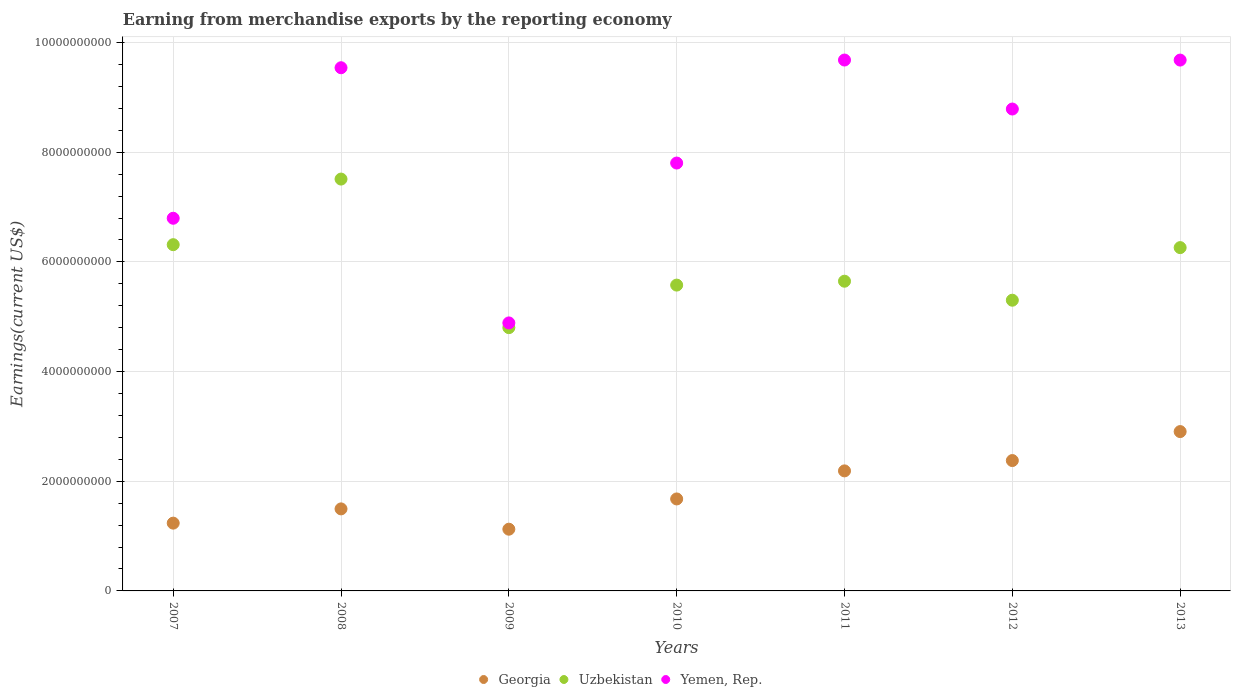How many different coloured dotlines are there?
Your answer should be very brief. 3. What is the amount earned from merchandise exports in Uzbekistan in 2009?
Ensure brevity in your answer.  4.80e+09. Across all years, what is the maximum amount earned from merchandise exports in Georgia?
Provide a succinct answer. 2.91e+09. Across all years, what is the minimum amount earned from merchandise exports in Georgia?
Your answer should be compact. 1.13e+09. In which year was the amount earned from merchandise exports in Yemen, Rep. maximum?
Make the answer very short. 2011. In which year was the amount earned from merchandise exports in Georgia minimum?
Your answer should be compact. 2009. What is the total amount earned from merchandise exports in Yemen, Rep. in the graph?
Provide a short and direct response. 5.72e+1. What is the difference between the amount earned from merchandise exports in Yemen, Rep. in 2009 and that in 2013?
Keep it short and to the point. -4.79e+09. What is the difference between the amount earned from merchandise exports in Uzbekistan in 2008 and the amount earned from merchandise exports in Yemen, Rep. in 2009?
Make the answer very short. 2.62e+09. What is the average amount earned from merchandise exports in Georgia per year?
Your answer should be very brief. 1.86e+09. In the year 2007, what is the difference between the amount earned from merchandise exports in Yemen, Rep. and amount earned from merchandise exports in Georgia?
Your answer should be compact. 5.56e+09. What is the ratio of the amount earned from merchandise exports in Uzbekistan in 2009 to that in 2011?
Offer a terse response. 0.85. Is the amount earned from merchandise exports in Yemen, Rep. in 2007 less than that in 2011?
Make the answer very short. Yes. What is the difference between the highest and the second highest amount earned from merchandise exports in Georgia?
Provide a short and direct response. 5.28e+08. What is the difference between the highest and the lowest amount earned from merchandise exports in Yemen, Rep.?
Offer a terse response. 4.79e+09. Is the sum of the amount earned from merchandise exports in Uzbekistan in 2011 and 2012 greater than the maximum amount earned from merchandise exports in Yemen, Rep. across all years?
Make the answer very short. Yes. Is the amount earned from merchandise exports in Uzbekistan strictly greater than the amount earned from merchandise exports in Georgia over the years?
Make the answer very short. Yes. Is the amount earned from merchandise exports in Uzbekistan strictly less than the amount earned from merchandise exports in Yemen, Rep. over the years?
Give a very brief answer. Yes. How many dotlines are there?
Provide a short and direct response. 3. What is the difference between two consecutive major ticks on the Y-axis?
Make the answer very short. 2.00e+09. Are the values on the major ticks of Y-axis written in scientific E-notation?
Give a very brief answer. No. What is the title of the graph?
Make the answer very short. Earning from merchandise exports by the reporting economy. Does "Moldova" appear as one of the legend labels in the graph?
Your response must be concise. No. What is the label or title of the X-axis?
Provide a succinct answer. Years. What is the label or title of the Y-axis?
Make the answer very short. Earnings(current US$). What is the Earnings(current US$) in Georgia in 2007?
Offer a very short reply. 1.24e+09. What is the Earnings(current US$) of Uzbekistan in 2007?
Offer a very short reply. 6.31e+09. What is the Earnings(current US$) of Yemen, Rep. in 2007?
Your answer should be compact. 6.80e+09. What is the Earnings(current US$) of Georgia in 2008?
Give a very brief answer. 1.50e+09. What is the Earnings(current US$) of Uzbekistan in 2008?
Your answer should be compact. 7.51e+09. What is the Earnings(current US$) in Yemen, Rep. in 2008?
Your response must be concise. 9.54e+09. What is the Earnings(current US$) in Georgia in 2009?
Offer a terse response. 1.13e+09. What is the Earnings(current US$) in Uzbekistan in 2009?
Ensure brevity in your answer.  4.80e+09. What is the Earnings(current US$) of Yemen, Rep. in 2009?
Give a very brief answer. 4.89e+09. What is the Earnings(current US$) in Georgia in 2010?
Your answer should be compact. 1.68e+09. What is the Earnings(current US$) in Uzbekistan in 2010?
Give a very brief answer. 5.58e+09. What is the Earnings(current US$) in Yemen, Rep. in 2010?
Provide a succinct answer. 7.80e+09. What is the Earnings(current US$) in Georgia in 2011?
Provide a short and direct response. 2.19e+09. What is the Earnings(current US$) of Uzbekistan in 2011?
Provide a short and direct response. 5.65e+09. What is the Earnings(current US$) of Yemen, Rep. in 2011?
Your answer should be compact. 9.68e+09. What is the Earnings(current US$) in Georgia in 2012?
Ensure brevity in your answer.  2.38e+09. What is the Earnings(current US$) in Uzbekistan in 2012?
Your response must be concise. 5.30e+09. What is the Earnings(current US$) of Yemen, Rep. in 2012?
Make the answer very short. 8.79e+09. What is the Earnings(current US$) of Georgia in 2013?
Provide a succinct answer. 2.91e+09. What is the Earnings(current US$) in Uzbekistan in 2013?
Your answer should be compact. 6.26e+09. What is the Earnings(current US$) of Yemen, Rep. in 2013?
Offer a terse response. 9.68e+09. Across all years, what is the maximum Earnings(current US$) in Georgia?
Offer a very short reply. 2.91e+09. Across all years, what is the maximum Earnings(current US$) in Uzbekistan?
Your answer should be compact. 7.51e+09. Across all years, what is the maximum Earnings(current US$) in Yemen, Rep.?
Provide a short and direct response. 9.68e+09. Across all years, what is the minimum Earnings(current US$) in Georgia?
Offer a very short reply. 1.13e+09. Across all years, what is the minimum Earnings(current US$) in Uzbekistan?
Make the answer very short. 4.80e+09. Across all years, what is the minimum Earnings(current US$) in Yemen, Rep.?
Provide a succinct answer. 4.89e+09. What is the total Earnings(current US$) of Georgia in the graph?
Your response must be concise. 1.30e+1. What is the total Earnings(current US$) in Uzbekistan in the graph?
Your answer should be very brief. 4.14e+1. What is the total Earnings(current US$) in Yemen, Rep. in the graph?
Your answer should be compact. 5.72e+1. What is the difference between the Earnings(current US$) of Georgia in 2007 and that in 2008?
Make the answer very short. -2.60e+08. What is the difference between the Earnings(current US$) in Uzbekistan in 2007 and that in 2008?
Ensure brevity in your answer.  -1.20e+09. What is the difference between the Earnings(current US$) in Yemen, Rep. in 2007 and that in 2008?
Your answer should be very brief. -2.75e+09. What is the difference between the Earnings(current US$) in Georgia in 2007 and that in 2009?
Your answer should be compact. 1.11e+08. What is the difference between the Earnings(current US$) in Uzbekistan in 2007 and that in 2009?
Your answer should be compact. 1.51e+09. What is the difference between the Earnings(current US$) of Yemen, Rep. in 2007 and that in 2009?
Provide a succinct answer. 1.91e+09. What is the difference between the Earnings(current US$) in Georgia in 2007 and that in 2010?
Make the answer very short. -4.41e+08. What is the difference between the Earnings(current US$) of Uzbekistan in 2007 and that in 2010?
Keep it short and to the point. 7.37e+08. What is the difference between the Earnings(current US$) of Yemen, Rep. in 2007 and that in 2010?
Your answer should be very brief. -1.01e+09. What is the difference between the Earnings(current US$) in Georgia in 2007 and that in 2011?
Make the answer very short. -9.53e+08. What is the difference between the Earnings(current US$) in Uzbekistan in 2007 and that in 2011?
Give a very brief answer. 6.66e+08. What is the difference between the Earnings(current US$) in Yemen, Rep. in 2007 and that in 2011?
Offer a very short reply. -2.89e+09. What is the difference between the Earnings(current US$) of Georgia in 2007 and that in 2012?
Keep it short and to the point. -1.14e+09. What is the difference between the Earnings(current US$) of Uzbekistan in 2007 and that in 2012?
Give a very brief answer. 1.01e+09. What is the difference between the Earnings(current US$) in Yemen, Rep. in 2007 and that in 2012?
Offer a terse response. -1.99e+09. What is the difference between the Earnings(current US$) in Georgia in 2007 and that in 2013?
Offer a very short reply. -1.67e+09. What is the difference between the Earnings(current US$) in Uzbekistan in 2007 and that in 2013?
Give a very brief answer. 5.35e+07. What is the difference between the Earnings(current US$) of Yemen, Rep. in 2007 and that in 2013?
Provide a short and direct response. -2.88e+09. What is the difference between the Earnings(current US$) of Georgia in 2008 and that in 2009?
Provide a short and direct response. 3.70e+08. What is the difference between the Earnings(current US$) of Uzbekistan in 2008 and that in 2009?
Your response must be concise. 2.71e+09. What is the difference between the Earnings(current US$) of Yemen, Rep. in 2008 and that in 2009?
Give a very brief answer. 4.65e+09. What is the difference between the Earnings(current US$) in Georgia in 2008 and that in 2010?
Offer a very short reply. -1.81e+08. What is the difference between the Earnings(current US$) in Uzbekistan in 2008 and that in 2010?
Provide a short and direct response. 1.93e+09. What is the difference between the Earnings(current US$) of Yemen, Rep. in 2008 and that in 2010?
Offer a terse response. 1.74e+09. What is the difference between the Earnings(current US$) of Georgia in 2008 and that in 2011?
Your answer should be very brief. -6.93e+08. What is the difference between the Earnings(current US$) in Uzbekistan in 2008 and that in 2011?
Ensure brevity in your answer.  1.86e+09. What is the difference between the Earnings(current US$) in Yemen, Rep. in 2008 and that in 2011?
Your answer should be compact. -1.40e+08. What is the difference between the Earnings(current US$) in Georgia in 2008 and that in 2012?
Give a very brief answer. -8.81e+08. What is the difference between the Earnings(current US$) in Uzbekistan in 2008 and that in 2012?
Keep it short and to the point. 2.21e+09. What is the difference between the Earnings(current US$) in Yemen, Rep. in 2008 and that in 2012?
Your answer should be compact. 7.53e+08. What is the difference between the Earnings(current US$) of Georgia in 2008 and that in 2013?
Your answer should be very brief. -1.41e+09. What is the difference between the Earnings(current US$) of Uzbekistan in 2008 and that in 2013?
Provide a short and direct response. 1.25e+09. What is the difference between the Earnings(current US$) of Yemen, Rep. in 2008 and that in 2013?
Your answer should be very brief. -1.40e+08. What is the difference between the Earnings(current US$) of Georgia in 2009 and that in 2010?
Your answer should be compact. -5.52e+08. What is the difference between the Earnings(current US$) in Uzbekistan in 2009 and that in 2010?
Your answer should be very brief. -7.76e+08. What is the difference between the Earnings(current US$) in Yemen, Rep. in 2009 and that in 2010?
Your answer should be compact. -2.92e+09. What is the difference between the Earnings(current US$) in Georgia in 2009 and that in 2011?
Ensure brevity in your answer.  -1.06e+09. What is the difference between the Earnings(current US$) of Uzbekistan in 2009 and that in 2011?
Provide a succinct answer. -8.47e+08. What is the difference between the Earnings(current US$) of Yemen, Rep. in 2009 and that in 2011?
Offer a terse response. -4.79e+09. What is the difference between the Earnings(current US$) in Georgia in 2009 and that in 2012?
Make the answer very short. -1.25e+09. What is the difference between the Earnings(current US$) in Uzbekistan in 2009 and that in 2012?
Offer a terse response. -5.00e+08. What is the difference between the Earnings(current US$) of Yemen, Rep. in 2009 and that in 2012?
Your response must be concise. -3.90e+09. What is the difference between the Earnings(current US$) in Georgia in 2009 and that in 2013?
Your answer should be very brief. -1.78e+09. What is the difference between the Earnings(current US$) in Uzbekistan in 2009 and that in 2013?
Offer a very short reply. -1.46e+09. What is the difference between the Earnings(current US$) in Yemen, Rep. in 2009 and that in 2013?
Provide a succinct answer. -4.79e+09. What is the difference between the Earnings(current US$) of Georgia in 2010 and that in 2011?
Your response must be concise. -5.12e+08. What is the difference between the Earnings(current US$) in Uzbekistan in 2010 and that in 2011?
Your response must be concise. -7.08e+07. What is the difference between the Earnings(current US$) of Yemen, Rep. in 2010 and that in 2011?
Make the answer very short. -1.88e+09. What is the difference between the Earnings(current US$) in Georgia in 2010 and that in 2012?
Ensure brevity in your answer.  -7.00e+08. What is the difference between the Earnings(current US$) in Uzbekistan in 2010 and that in 2012?
Your answer should be compact. 2.76e+08. What is the difference between the Earnings(current US$) of Yemen, Rep. in 2010 and that in 2012?
Your answer should be very brief. -9.85e+08. What is the difference between the Earnings(current US$) of Georgia in 2010 and that in 2013?
Make the answer very short. -1.23e+09. What is the difference between the Earnings(current US$) in Uzbekistan in 2010 and that in 2013?
Ensure brevity in your answer.  -6.84e+08. What is the difference between the Earnings(current US$) in Yemen, Rep. in 2010 and that in 2013?
Your response must be concise. -1.88e+09. What is the difference between the Earnings(current US$) of Georgia in 2011 and that in 2012?
Ensure brevity in your answer.  -1.88e+08. What is the difference between the Earnings(current US$) of Uzbekistan in 2011 and that in 2012?
Offer a terse response. 3.47e+08. What is the difference between the Earnings(current US$) of Yemen, Rep. in 2011 and that in 2012?
Offer a very short reply. 8.94e+08. What is the difference between the Earnings(current US$) of Georgia in 2011 and that in 2013?
Keep it short and to the point. -7.17e+08. What is the difference between the Earnings(current US$) in Uzbekistan in 2011 and that in 2013?
Provide a short and direct response. -6.13e+08. What is the difference between the Earnings(current US$) in Yemen, Rep. in 2011 and that in 2013?
Keep it short and to the point. 8.93e+05. What is the difference between the Earnings(current US$) in Georgia in 2012 and that in 2013?
Your answer should be very brief. -5.28e+08. What is the difference between the Earnings(current US$) of Uzbekistan in 2012 and that in 2013?
Make the answer very short. -9.59e+08. What is the difference between the Earnings(current US$) in Yemen, Rep. in 2012 and that in 2013?
Your response must be concise. -8.93e+08. What is the difference between the Earnings(current US$) of Georgia in 2007 and the Earnings(current US$) of Uzbekistan in 2008?
Ensure brevity in your answer.  -6.27e+09. What is the difference between the Earnings(current US$) of Georgia in 2007 and the Earnings(current US$) of Yemen, Rep. in 2008?
Provide a short and direct response. -8.31e+09. What is the difference between the Earnings(current US$) of Uzbekistan in 2007 and the Earnings(current US$) of Yemen, Rep. in 2008?
Your answer should be compact. -3.23e+09. What is the difference between the Earnings(current US$) of Georgia in 2007 and the Earnings(current US$) of Uzbekistan in 2009?
Give a very brief answer. -3.57e+09. What is the difference between the Earnings(current US$) of Georgia in 2007 and the Earnings(current US$) of Yemen, Rep. in 2009?
Your response must be concise. -3.65e+09. What is the difference between the Earnings(current US$) of Uzbekistan in 2007 and the Earnings(current US$) of Yemen, Rep. in 2009?
Make the answer very short. 1.43e+09. What is the difference between the Earnings(current US$) in Georgia in 2007 and the Earnings(current US$) in Uzbekistan in 2010?
Your answer should be compact. -4.34e+09. What is the difference between the Earnings(current US$) of Georgia in 2007 and the Earnings(current US$) of Yemen, Rep. in 2010?
Keep it short and to the point. -6.57e+09. What is the difference between the Earnings(current US$) of Uzbekistan in 2007 and the Earnings(current US$) of Yemen, Rep. in 2010?
Your answer should be very brief. -1.49e+09. What is the difference between the Earnings(current US$) in Georgia in 2007 and the Earnings(current US$) in Uzbekistan in 2011?
Your response must be concise. -4.41e+09. What is the difference between the Earnings(current US$) in Georgia in 2007 and the Earnings(current US$) in Yemen, Rep. in 2011?
Your answer should be very brief. -8.45e+09. What is the difference between the Earnings(current US$) of Uzbekistan in 2007 and the Earnings(current US$) of Yemen, Rep. in 2011?
Provide a succinct answer. -3.37e+09. What is the difference between the Earnings(current US$) in Georgia in 2007 and the Earnings(current US$) in Uzbekistan in 2012?
Keep it short and to the point. -4.07e+09. What is the difference between the Earnings(current US$) in Georgia in 2007 and the Earnings(current US$) in Yemen, Rep. in 2012?
Offer a very short reply. -7.55e+09. What is the difference between the Earnings(current US$) of Uzbekistan in 2007 and the Earnings(current US$) of Yemen, Rep. in 2012?
Your answer should be compact. -2.47e+09. What is the difference between the Earnings(current US$) in Georgia in 2007 and the Earnings(current US$) in Uzbekistan in 2013?
Your answer should be compact. -5.02e+09. What is the difference between the Earnings(current US$) of Georgia in 2007 and the Earnings(current US$) of Yemen, Rep. in 2013?
Ensure brevity in your answer.  -8.44e+09. What is the difference between the Earnings(current US$) of Uzbekistan in 2007 and the Earnings(current US$) of Yemen, Rep. in 2013?
Give a very brief answer. -3.37e+09. What is the difference between the Earnings(current US$) in Georgia in 2008 and the Earnings(current US$) in Uzbekistan in 2009?
Keep it short and to the point. -3.31e+09. What is the difference between the Earnings(current US$) of Georgia in 2008 and the Earnings(current US$) of Yemen, Rep. in 2009?
Give a very brief answer. -3.39e+09. What is the difference between the Earnings(current US$) of Uzbekistan in 2008 and the Earnings(current US$) of Yemen, Rep. in 2009?
Give a very brief answer. 2.62e+09. What is the difference between the Earnings(current US$) in Georgia in 2008 and the Earnings(current US$) in Uzbekistan in 2010?
Provide a succinct answer. -4.08e+09. What is the difference between the Earnings(current US$) in Georgia in 2008 and the Earnings(current US$) in Yemen, Rep. in 2010?
Keep it short and to the point. -6.31e+09. What is the difference between the Earnings(current US$) of Uzbekistan in 2008 and the Earnings(current US$) of Yemen, Rep. in 2010?
Give a very brief answer. -2.92e+08. What is the difference between the Earnings(current US$) in Georgia in 2008 and the Earnings(current US$) in Uzbekistan in 2011?
Ensure brevity in your answer.  -4.15e+09. What is the difference between the Earnings(current US$) of Georgia in 2008 and the Earnings(current US$) of Yemen, Rep. in 2011?
Offer a terse response. -8.19e+09. What is the difference between the Earnings(current US$) in Uzbekistan in 2008 and the Earnings(current US$) in Yemen, Rep. in 2011?
Keep it short and to the point. -2.17e+09. What is the difference between the Earnings(current US$) of Georgia in 2008 and the Earnings(current US$) of Uzbekistan in 2012?
Your answer should be compact. -3.81e+09. What is the difference between the Earnings(current US$) in Georgia in 2008 and the Earnings(current US$) in Yemen, Rep. in 2012?
Offer a terse response. -7.29e+09. What is the difference between the Earnings(current US$) of Uzbekistan in 2008 and the Earnings(current US$) of Yemen, Rep. in 2012?
Offer a terse response. -1.28e+09. What is the difference between the Earnings(current US$) of Georgia in 2008 and the Earnings(current US$) of Uzbekistan in 2013?
Provide a succinct answer. -4.76e+09. What is the difference between the Earnings(current US$) in Georgia in 2008 and the Earnings(current US$) in Yemen, Rep. in 2013?
Ensure brevity in your answer.  -8.18e+09. What is the difference between the Earnings(current US$) of Uzbekistan in 2008 and the Earnings(current US$) of Yemen, Rep. in 2013?
Offer a terse response. -2.17e+09. What is the difference between the Earnings(current US$) in Georgia in 2009 and the Earnings(current US$) in Uzbekistan in 2010?
Your response must be concise. -4.45e+09. What is the difference between the Earnings(current US$) in Georgia in 2009 and the Earnings(current US$) in Yemen, Rep. in 2010?
Offer a terse response. -6.68e+09. What is the difference between the Earnings(current US$) in Uzbekistan in 2009 and the Earnings(current US$) in Yemen, Rep. in 2010?
Provide a short and direct response. -3.00e+09. What is the difference between the Earnings(current US$) in Georgia in 2009 and the Earnings(current US$) in Uzbekistan in 2011?
Offer a very short reply. -4.52e+09. What is the difference between the Earnings(current US$) in Georgia in 2009 and the Earnings(current US$) in Yemen, Rep. in 2011?
Make the answer very short. -8.56e+09. What is the difference between the Earnings(current US$) in Uzbekistan in 2009 and the Earnings(current US$) in Yemen, Rep. in 2011?
Offer a very short reply. -4.88e+09. What is the difference between the Earnings(current US$) of Georgia in 2009 and the Earnings(current US$) of Uzbekistan in 2012?
Provide a short and direct response. -4.18e+09. What is the difference between the Earnings(current US$) in Georgia in 2009 and the Earnings(current US$) in Yemen, Rep. in 2012?
Your response must be concise. -7.66e+09. What is the difference between the Earnings(current US$) of Uzbekistan in 2009 and the Earnings(current US$) of Yemen, Rep. in 2012?
Make the answer very short. -3.99e+09. What is the difference between the Earnings(current US$) in Georgia in 2009 and the Earnings(current US$) in Uzbekistan in 2013?
Give a very brief answer. -5.14e+09. What is the difference between the Earnings(current US$) in Georgia in 2009 and the Earnings(current US$) in Yemen, Rep. in 2013?
Make the answer very short. -8.56e+09. What is the difference between the Earnings(current US$) of Uzbekistan in 2009 and the Earnings(current US$) of Yemen, Rep. in 2013?
Give a very brief answer. -4.88e+09. What is the difference between the Earnings(current US$) in Georgia in 2010 and the Earnings(current US$) in Uzbekistan in 2011?
Your response must be concise. -3.97e+09. What is the difference between the Earnings(current US$) in Georgia in 2010 and the Earnings(current US$) in Yemen, Rep. in 2011?
Your answer should be compact. -8.00e+09. What is the difference between the Earnings(current US$) in Uzbekistan in 2010 and the Earnings(current US$) in Yemen, Rep. in 2011?
Provide a succinct answer. -4.10e+09. What is the difference between the Earnings(current US$) in Georgia in 2010 and the Earnings(current US$) in Uzbekistan in 2012?
Your answer should be very brief. -3.62e+09. What is the difference between the Earnings(current US$) in Georgia in 2010 and the Earnings(current US$) in Yemen, Rep. in 2012?
Ensure brevity in your answer.  -7.11e+09. What is the difference between the Earnings(current US$) of Uzbekistan in 2010 and the Earnings(current US$) of Yemen, Rep. in 2012?
Provide a succinct answer. -3.21e+09. What is the difference between the Earnings(current US$) in Georgia in 2010 and the Earnings(current US$) in Uzbekistan in 2013?
Your response must be concise. -4.58e+09. What is the difference between the Earnings(current US$) in Georgia in 2010 and the Earnings(current US$) in Yemen, Rep. in 2013?
Provide a succinct answer. -8.00e+09. What is the difference between the Earnings(current US$) of Uzbekistan in 2010 and the Earnings(current US$) of Yemen, Rep. in 2013?
Keep it short and to the point. -4.10e+09. What is the difference between the Earnings(current US$) in Georgia in 2011 and the Earnings(current US$) in Uzbekistan in 2012?
Make the answer very short. -3.11e+09. What is the difference between the Earnings(current US$) of Georgia in 2011 and the Earnings(current US$) of Yemen, Rep. in 2012?
Keep it short and to the point. -6.60e+09. What is the difference between the Earnings(current US$) in Uzbekistan in 2011 and the Earnings(current US$) in Yemen, Rep. in 2012?
Provide a succinct answer. -3.14e+09. What is the difference between the Earnings(current US$) of Georgia in 2011 and the Earnings(current US$) of Uzbekistan in 2013?
Keep it short and to the point. -4.07e+09. What is the difference between the Earnings(current US$) in Georgia in 2011 and the Earnings(current US$) in Yemen, Rep. in 2013?
Your answer should be very brief. -7.49e+09. What is the difference between the Earnings(current US$) of Uzbekistan in 2011 and the Earnings(current US$) of Yemen, Rep. in 2013?
Provide a short and direct response. -4.03e+09. What is the difference between the Earnings(current US$) in Georgia in 2012 and the Earnings(current US$) in Uzbekistan in 2013?
Provide a succinct answer. -3.88e+09. What is the difference between the Earnings(current US$) in Georgia in 2012 and the Earnings(current US$) in Yemen, Rep. in 2013?
Offer a terse response. -7.30e+09. What is the difference between the Earnings(current US$) in Uzbekistan in 2012 and the Earnings(current US$) in Yemen, Rep. in 2013?
Keep it short and to the point. -4.38e+09. What is the average Earnings(current US$) of Georgia per year?
Your answer should be compact. 1.86e+09. What is the average Earnings(current US$) of Uzbekistan per year?
Make the answer very short. 5.92e+09. What is the average Earnings(current US$) in Yemen, Rep. per year?
Give a very brief answer. 8.17e+09. In the year 2007, what is the difference between the Earnings(current US$) of Georgia and Earnings(current US$) of Uzbekistan?
Ensure brevity in your answer.  -5.08e+09. In the year 2007, what is the difference between the Earnings(current US$) in Georgia and Earnings(current US$) in Yemen, Rep.?
Your answer should be very brief. -5.56e+09. In the year 2007, what is the difference between the Earnings(current US$) of Uzbekistan and Earnings(current US$) of Yemen, Rep.?
Give a very brief answer. -4.82e+08. In the year 2008, what is the difference between the Earnings(current US$) in Georgia and Earnings(current US$) in Uzbekistan?
Give a very brief answer. -6.01e+09. In the year 2008, what is the difference between the Earnings(current US$) of Georgia and Earnings(current US$) of Yemen, Rep.?
Give a very brief answer. -8.05e+09. In the year 2008, what is the difference between the Earnings(current US$) of Uzbekistan and Earnings(current US$) of Yemen, Rep.?
Your response must be concise. -2.03e+09. In the year 2009, what is the difference between the Earnings(current US$) in Georgia and Earnings(current US$) in Uzbekistan?
Your answer should be very brief. -3.68e+09. In the year 2009, what is the difference between the Earnings(current US$) in Georgia and Earnings(current US$) in Yemen, Rep.?
Provide a short and direct response. -3.76e+09. In the year 2009, what is the difference between the Earnings(current US$) in Uzbekistan and Earnings(current US$) in Yemen, Rep.?
Ensure brevity in your answer.  -8.63e+07. In the year 2010, what is the difference between the Earnings(current US$) of Georgia and Earnings(current US$) of Uzbekistan?
Your answer should be very brief. -3.90e+09. In the year 2010, what is the difference between the Earnings(current US$) in Georgia and Earnings(current US$) in Yemen, Rep.?
Your answer should be compact. -6.13e+09. In the year 2010, what is the difference between the Earnings(current US$) of Uzbekistan and Earnings(current US$) of Yemen, Rep.?
Provide a succinct answer. -2.23e+09. In the year 2011, what is the difference between the Earnings(current US$) of Georgia and Earnings(current US$) of Uzbekistan?
Your response must be concise. -3.46e+09. In the year 2011, what is the difference between the Earnings(current US$) of Georgia and Earnings(current US$) of Yemen, Rep.?
Make the answer very short. -7.49e+09. In the year 2011, what is the difference between the Earnings(current US$) of Uzbekistan and Earnings(current US$) of Yemen, Rep.?
Make the answer very short. -4.03e+09. In the year 2012, what is the difference between the Earnings(current US$) of Georgia and Earnings(current US$) of Uzbekistan?
Your answer should be compact. -2.92e+09. In the year 2012, what is the difference between the Earnings(current US$) in Georgia and Earnings(current US$) in Yemen, Rep.?
Your answer should be very brief. -6.41e+09. In the year 2012, what is the difference between the Earnings(current US$) of Uzbekistan and Earnings(current US$) of Yemen, Rep.?
Offer a terse response. -3.49e+09. In the year 2013, what is the difference between the Earnings(current US$) in Georgia and Earnings(current US$) in Uzbekistan?
Provide a short and direct response. -3.36e+09. In the year 2013, what is the difference between the Earnings(current US$) in Georgia and Earnings(current US$) in Yemen, Rep.?
Your answer should be compact. -6.78e+09. In the year 2013, what is the difference between the Earnings(current US$) in Uzbekistan and Earnings(current US$) in Yemen, Rep.?
Ensure brevity in your answer.  -3.42e+09. What is the ratio of the Earnings(current US$) of Georgia in 2007 to that in 2008?
Your answer should be very brief. 0.83. What is the ratio of the Earnings(current US$) of Uzbekistan in 2007 to that in 2008?
Give a very brief answer. 0.84. What is the ratio of the Earnings(current US$) of Yemen, Rep. in 2007 to that in 2008?
Make the answer very short. 0.71. What is the ratio of the Earnings(current US$) of Georgia in 2007 to that in 2009?
Ensure brevity in your answer.  1.1. What is the ratio of the Earnings(current US$) of Uzbekistan in 2007 to that in 2009?
Offer a terse response. 1.32. What is the ratio of the Earnings(current US$) in Yemen, Rep. in 2007 to that in 2009?
Provide a succinct answer. 1.39. What is the ratio of the Earnings(current US$) in Georgia in 2007 to that in 2010?
Offer a very short reply. 0.74. What is the ratio of the Earnings(current US$) of Uzbekistan in 2007 to that in 2010?
Your answer should be compact. 1.13. What is the ratio of the Earnings(current US$) in Yemen, Rep. in 2007 to that in 2010?
Provide a succinct answer. 0.87. What is the ratio of the Earnings(current US$) in Georgia in 2007 to that in 2011?
Your answer should be very brief. 0.56. What is the ratio of the Earnings(current US$) in Uzbekistan in 2007 to that in 2011?
Offer a terse response. 1.12. What is the ratio of the Earnings(current US$) in Yemen, Rep. in 2007 to that in 2011?
Your answer should be very brief. 0.7. What is the ratio of the Earnings(current US$) of Georgia in 2007 to that in 2012?
Your response must be concise. 0.52. What is the ratio of the Earnings(current US$) of Uzbekistan in 2007 to that in 2012?
Your answer should be compact. 1.19. What is the ratio of the Earnings(current US$) of Yemen, Rep. in 2007 to that in 2012?
Ensure brevity in your answer.  0.77. What is the ratio of the Earnings(current US$) in Georgia in 2007 to that in 2013?
Keep it short and to the point. 0.43. What is the ratio of the Earnings(current US$) of Uzbekistan in 2007 to that in 2013?
Ensure brevity in your answer.  1.01. What is the ratio of the Earnings(current US$) in Yemen, Rep. in 2007 to that in 2013?
Ensure brevity in your answer.  0.7. What is the ratio of the Earnings(current US$) of Georgia in 2008 to that in 2009?
Make the answer very short. 1.33. What is the ratio of the Earnings(current US$) of Uzbekistan in 2008 to that in 2009?
Offer a terse response. 1.56. What is the ratio of the Earnings(current US$) in Yemen, Rep. in 2008 to that in 2009?
Your response must be concise. 1.95. What is the ratio of the Earnings(current US$) of Georgia in 2008 to that in 2010?
Give a very brief answer. 0.89. What is the ratio of the Earnings(current US$) in Uzbekistan in 2008 to that in 2010?
Make the answer very short. 1.35. What is the ratio of the Earnings(current US$) of Yemen, Rep. in 2008 to that in 2010?
Your response must be concise. 1.22. What is the ratio of the Earnings(current US$) of Georgia in 2008 to that in 2011?
Your response must be concise. 0.68. What is the ratio of the Earnings(current US$) in Uzbekistan in 2008 to that in 2011?
Ensure brevity in your answer.  1.33. What is the ratio of the Earnings(current US$) of Yemen, Rep. in 2008 to that in 2011?
Your response must be concise. 0.99. What is the ratio of the Earnings(current US$) in Georgia in 2008 to that in 2012?
Offer a very short reply. 0.63. What is the ratio of the Earnings(current US$) of Uzbekistan in 2008 to that in 2012?
Make the answer very short. 1.42. What is the ratio of the Earnings(current US$) of Yemen, Rep. in 2008 to that in 2012?
Offer a terse response. 1.09. What is the ratio of the Earnings(current US$) of Georgia in 2008 to that in 2013?
Offer a terse response. 0.51. What is the ratio of the Earnings(current US$) in Uzbekistan in 2008 to that in 2013?
Provide a succinct answer. 1.2. What is the ratio of the Earnings(current US$) in Yemen, Rep. in 2008 to that in 2013?
Offer a very short reply. 0.99. What is the ratio of the Earnings(current US$) of Georgia in 2009 to that in 2010?
Your answer should be very brief. 0.67. What is the ratio of the Earnings(current US$) of Uzbekistan in 2009 to that in 2010?
Your response must be concise. 0.86. What is the ratio of the Earnings(current US$) of Yemen, Rep. in 2009 to that in 2010?
Provide a short and direct response. 0.63. What is the ratio of the Earnings(current US$) in Georgia in 2009 to that in 2011?
Provide a succinct answer. 0.51. What is the ratio of the Earnings(current US$) of Uzbekistan in 2009 to that in 2011?
Your answer should be very brief. 0.85. What is the ratio of the Earnings(current US$) in Yemen, Rep. in 2009 to that in 2011?
Offer a very short reply. 0.5. What is the ratio of the Earnings(current US$) of Georgia in 2009 to that in 2012?
Offer a terse response. 0.47. What is the ratio of the Earnings(current US$) of Uzbekistan in 2009 to that in 2012?
Offer a very short reply. 0.91. What is the ratio of the Earnings(current US$) of Yemen, Rep. in 2009 to that in 2012?
Offer a terse response. 0.56. What is the ratio of the Earnings(current US$) in Georgia in 2009 to that in 2013?
Make the answer very short. 0.39. What is the ratio of the Earnings(current US$) in Uzbekistan in 2009 to that in 2013?
Keep it short and to the point. 0.77. What is the ratio of the Earnings(current US$) of Yemen, Rep. in 2009 to that in 2013?
Keep it short and to the point. 0.5. What is the ratio of the Earnings(current US$) of Georgia in 2010 to that in 2011?
Your answer should be compact. 0.77. What is the ratio of the Earnings(current US$) of Uzbekistan in 2010 to that in 2011?
Offer a very short reply. 0.99. What is the ratio of the Earnings(current US$) in Yemen, Rep. in 2010 to that in 2011?
Your response must be concise. 0.81. What is the ratio of the Earnings(current US$) of Georgia in 2010 to that in 2012?
Ensure brevity in your answer.  0.71. What is the ratio of the Earnings(current US$) in Uzbekistan in 2010 to that in 2012?
Keep it short and to the point. 1.05. What is the ratio of the Earnings(current US$) in Yemen, Rep. in 2010 to that in 2012?
Make the answer very short. 0.89. What is the ratio of the Earnings(current US$) in Georgia in 2010 to that in 2013?
Provide a succinct answer. 0.58. What is the ratio of the Earnings(current US$) of Uzbekistan in 2010 to that in 2013?
Provide a short and direct response. 0.89. What is the ratio of the Earnings(current US$) in Yemen, Rep. in 2010 to that in 2013?
Provide a short and direct response. 0.81. What is the ratio of the Earnings(current US$) in Georgia in 2011 to that in 2012?
Your answer should be very brief. 0.92. What is the ratio of the Earnings(current US$) of Uzbekistan in 2011 to that in 2012?
Keep it short and to the point. 1.07. What is the ratio of the Earnings(current US$) of Yemen, Rep. in 2011 to that in 2012?
Give a very brief answer. 1.1. What is the ratio of the Earnings(current US$) in Georgia in 2011 to that in 2013?
Provide a succinct answer. 0.75. What is the ratio of the Earnings(current US$) in Uzbekistan in 2011 to that in 2013?
Keep it short and to the point. 0.9. What is the ratio of the Earnings(current US$) in Georgia in 2012 to that in 2013?
Keep it short and to the point. 0.82. What is the ratio of the Earnings(current US$) in Uzbekistan in 2012 to that in 2013?
Provide a succinct answer. 0.85. What is the ratio of the Earnings(current US$) of Yemen, Rep. in 2012 to that in 2013?
Ensure brevity in your answer.  0.91. What is the difference between the highest and the second highest Earnings(current US$) in Georgia?
Your answer should be very brief. 5.28e+08. What is the difference between the highest and the second highest Earnings(current US$) in Uzbekistan?
Give a very brief answer. 1.20e+09. What is the difference between the highest and the second highest Earnings(current US$) in Yemen, Rep.?
Your answer should be compact. 8.93e+05. What is the difference between the highest and the lowest Earnings(current US$) in Georgia?
Give a very brief answer. 1.78e+09. What is the difference between the highest and the lowest Earnings(current US$) in Uzbekistan?
Keep it short and to the point. 2.71e+09. What is the difference between the highest and the lowest Earnings(current US$) of Yemen, Rep.?
Offer a terse response. 4.79e+09. 